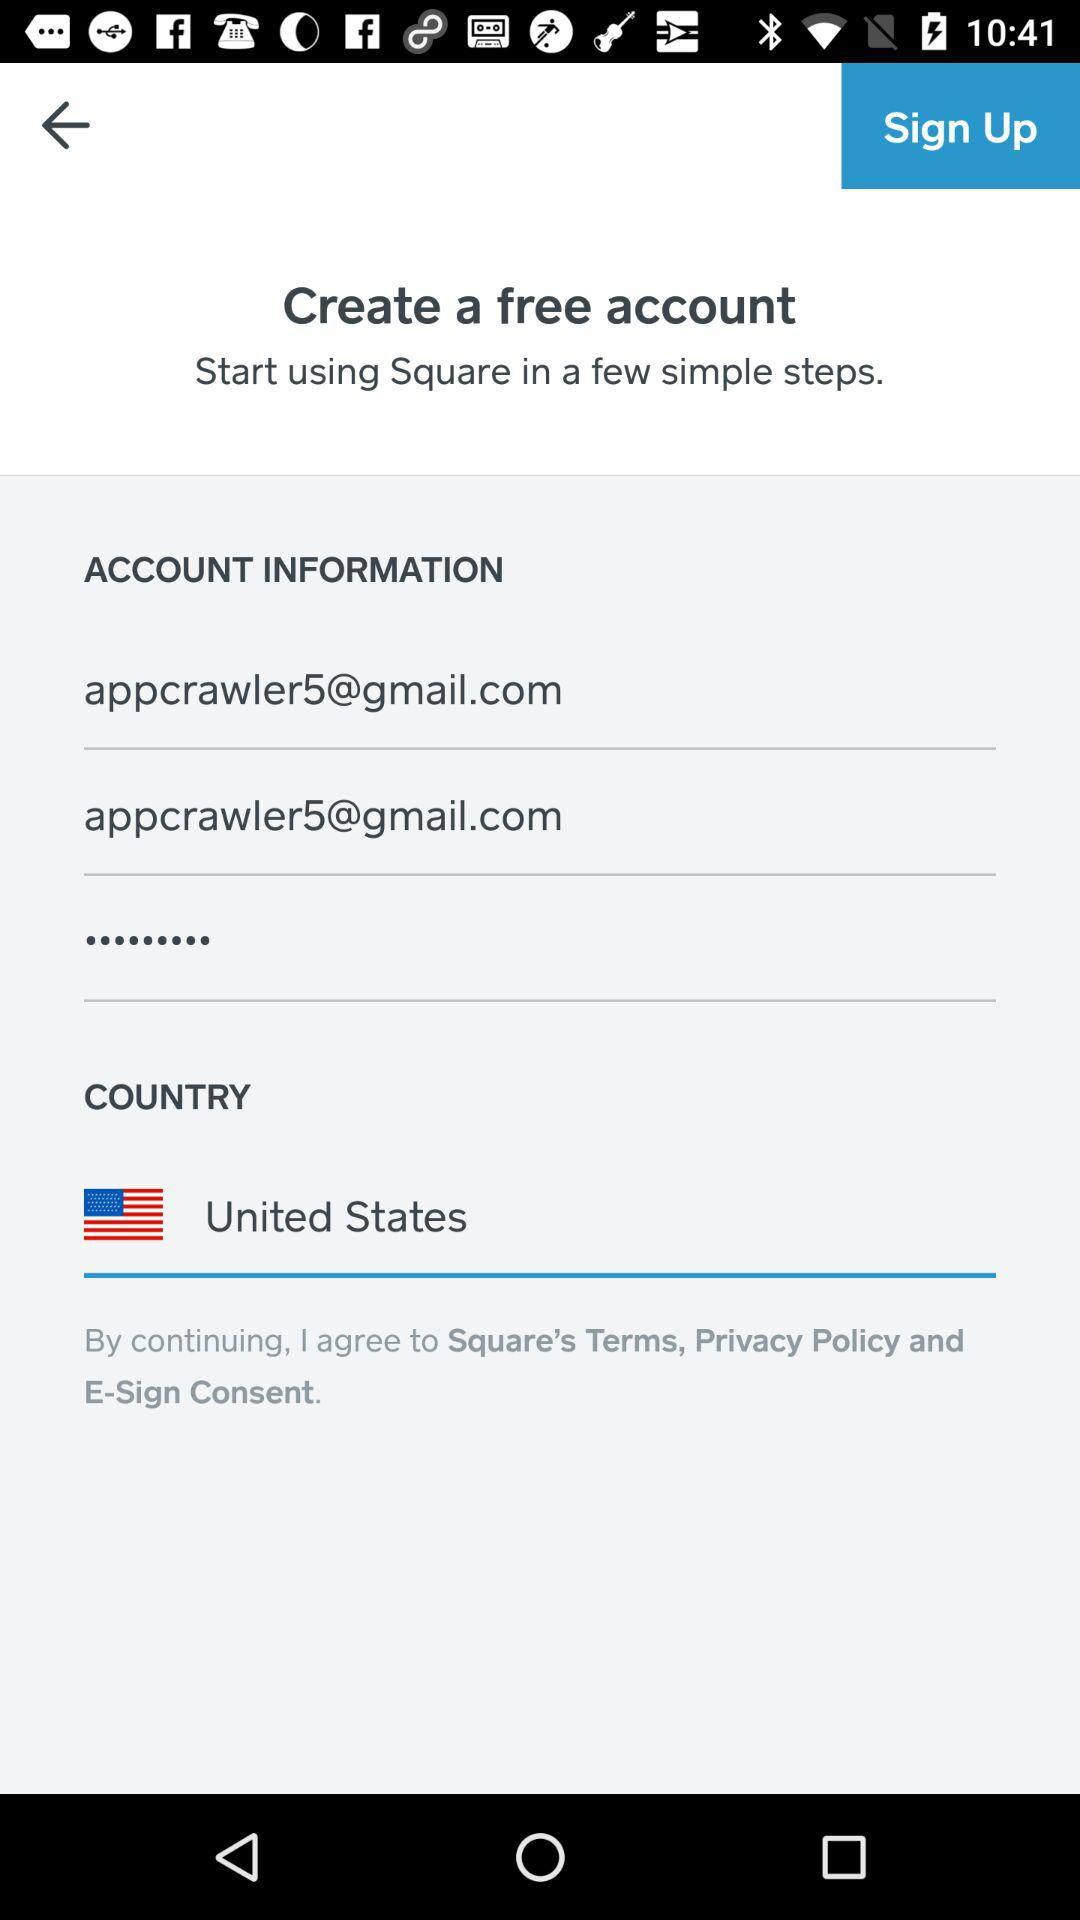What is the name of the application? The name of the application is "Square". 